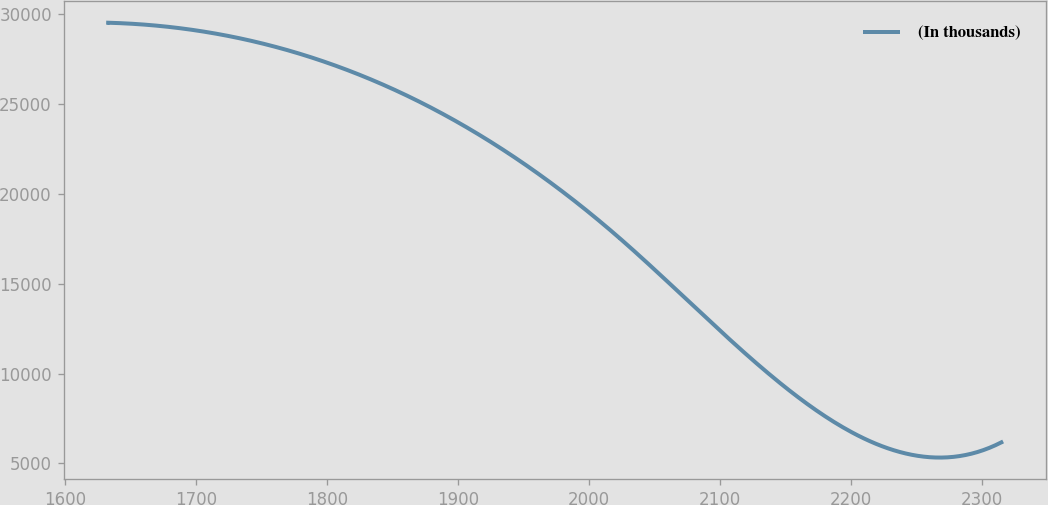<chart> <loc_0><loc_0><loc_500><loc_500><line_chart><ecel><fcel>(In thousands)<nl><fcel>1632.75<fcel>29526.5<nl><fcel>1938.32<fcel>22262.9<nl><fcel>2022.85<fcel>17561<nl><fcel>2162.81<fcel>8507.35<nl><fcel>2314.68<fcel>6171.88<nl></chart> 